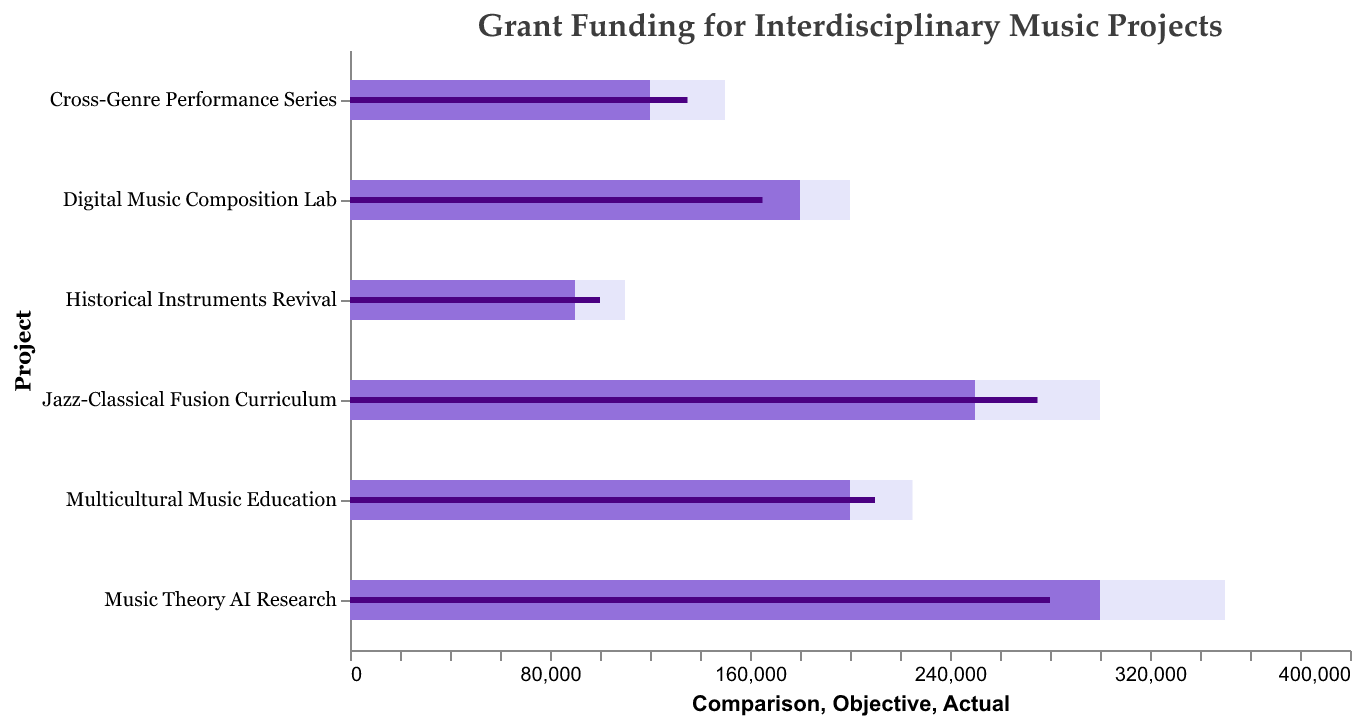What is the title of the chart? The title of the chart is displayed at the top, indicating what the chart is showing.
Answer: Grant Funding for Interdisciplinary Music Projects Which project received the highest actual grant funding? By looking at the "Actual" bars, the longest bar is corresponding to the project name.
Answer: Jazz-Classical Fusion Curriculum How much did the Digital Music Composition Lab fall short of its funding objective? The objective for the Digital Music Composition Lab is 180,000 while the actual funding is 165,000. Subtract the actual from the objective (180,000 - 165,000).
Answer: 15,000 Which projects surpassed their funding objectives? Identify the projects where the "Actual" bar exceeds the "Objective" bar. These projects are Jazz-Classical Fusion Curriculum, Cross-Genre Performance Series, Historical Instruments Revival, and Multicultural Music Education.
Answer: Jazz-Classical Fusion Curriculum, Cross-Genre Performance Series, Historical Instruments Revival, Multicultural Music Education Which project had the largest gap between its actual funding and comparison value? Calculate the difference between the "Actual" and "Comparison" values for each project. The largest gap is for Music Theory AI Research (350,000 - 280,000 = 70,000).
Answer: Music Theory AI Research What is the total objective funding for all projects combined? Add up all the objective values: 250,000 + 180,000 + 120,000 + 300,000 + 90,000 + 200,000.
Answer: 1,140,000 How much more funding does Historical Instruments Revival need to meet its comparison value? Subtract the actual funding from the comparison value for Historical Instruments Revival (110,000 - 100,000).
Answer: 10,000 Which project received the lowest actual funding? By identifying the shortest "Actual" bar, the project is identified.
Answer: Digital Music Composition Lab Arrange all projects based on their actual funding in descending order. Order the projects based on the length of their "Actual" bars from longest to shortest. The order is Jazz-Classical Fusion Curriculum, Multicultural Music Education, Music Theory AI Research, Cross-Genre Performance Series, Historical Instruments Revival, Digital Music Composition Lab.
Answer: Jazz-Classical Fusion Curriculum, Multicultural Music Education, Music Theory AI Research, Cross-Genre Performance Series, Historical Instruments Revival, Digital Music Composition Lab 